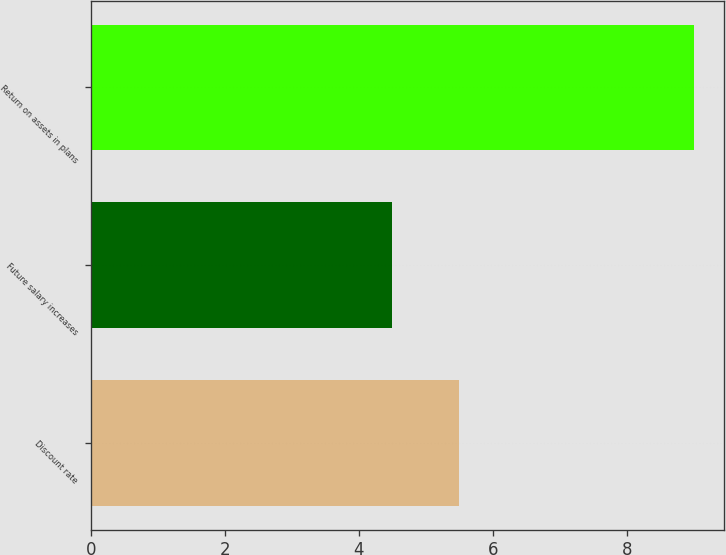Convert chart to OTSL. <chart><loc_0><loc_0><loc_500><loc_500><bar_chart><fcel>Discount rate<fcel>Future salary increases<fcel>Return on assets in plans<nl><fcel>5.5<fcel>4.5<fcel>9<nl></chart> 